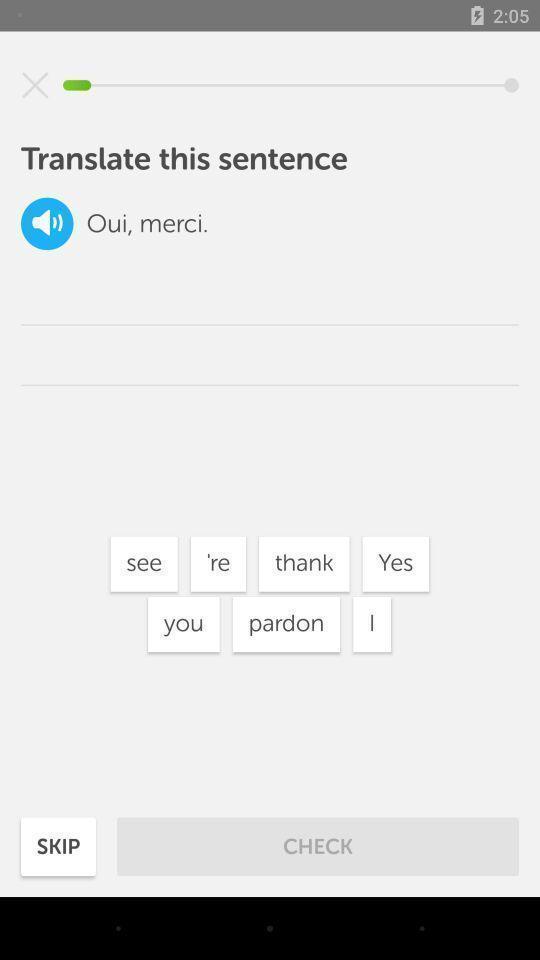What can you discern from this picture? Page displaying with language translation application. 